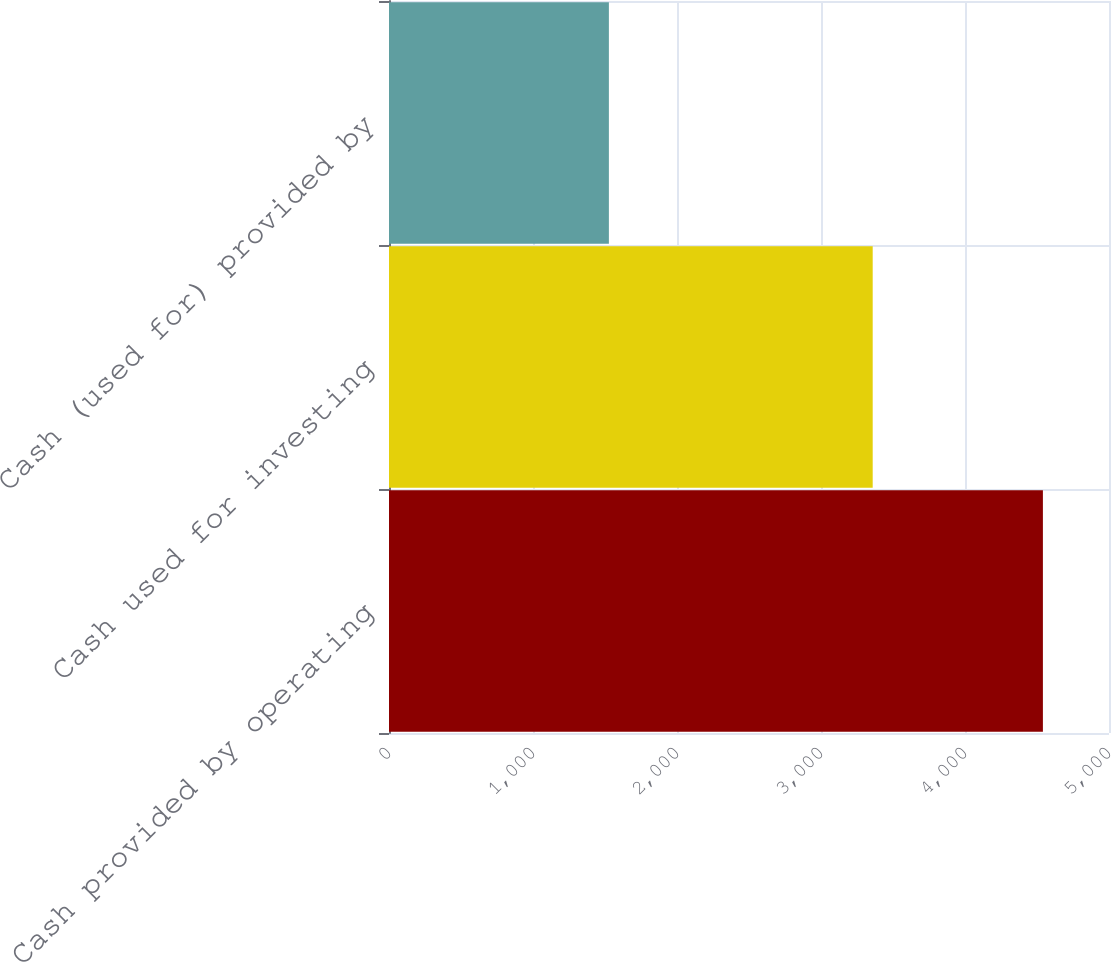Convert chart. <chart><loc_0><loc_0><loc_500><loc_500><bar_chart><fcel>Cash provided by operating<fcel>Cash used for investing<fcel>Cash (used for) provided by<nl><fcel>4541<fcel>3359<fcel>1527<nl></chart> 